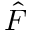Convert formula to latex. <formula><loc_0><loc_0><loc_500><loc_500>\hat { F }</formula> 